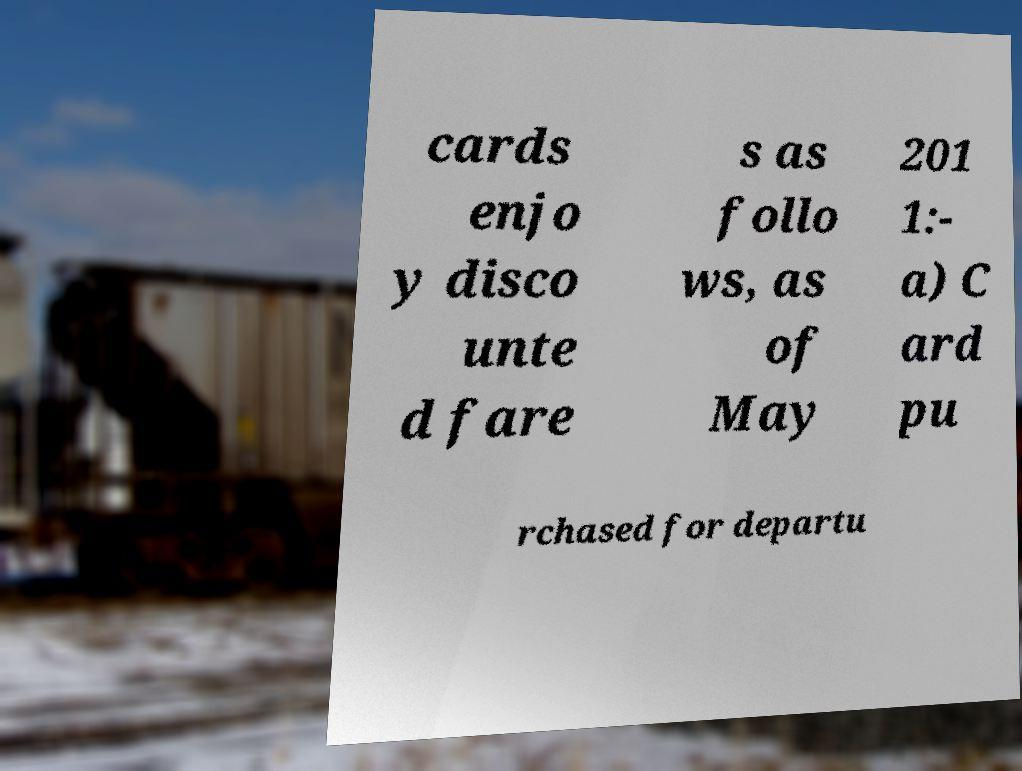There's text embedded in this image that I need extracted. Can you transcribe it verbatim? cards enjo y disco unte d fare s as follo ws, as of May 201 1:- a) C ard pu rchased for departu 